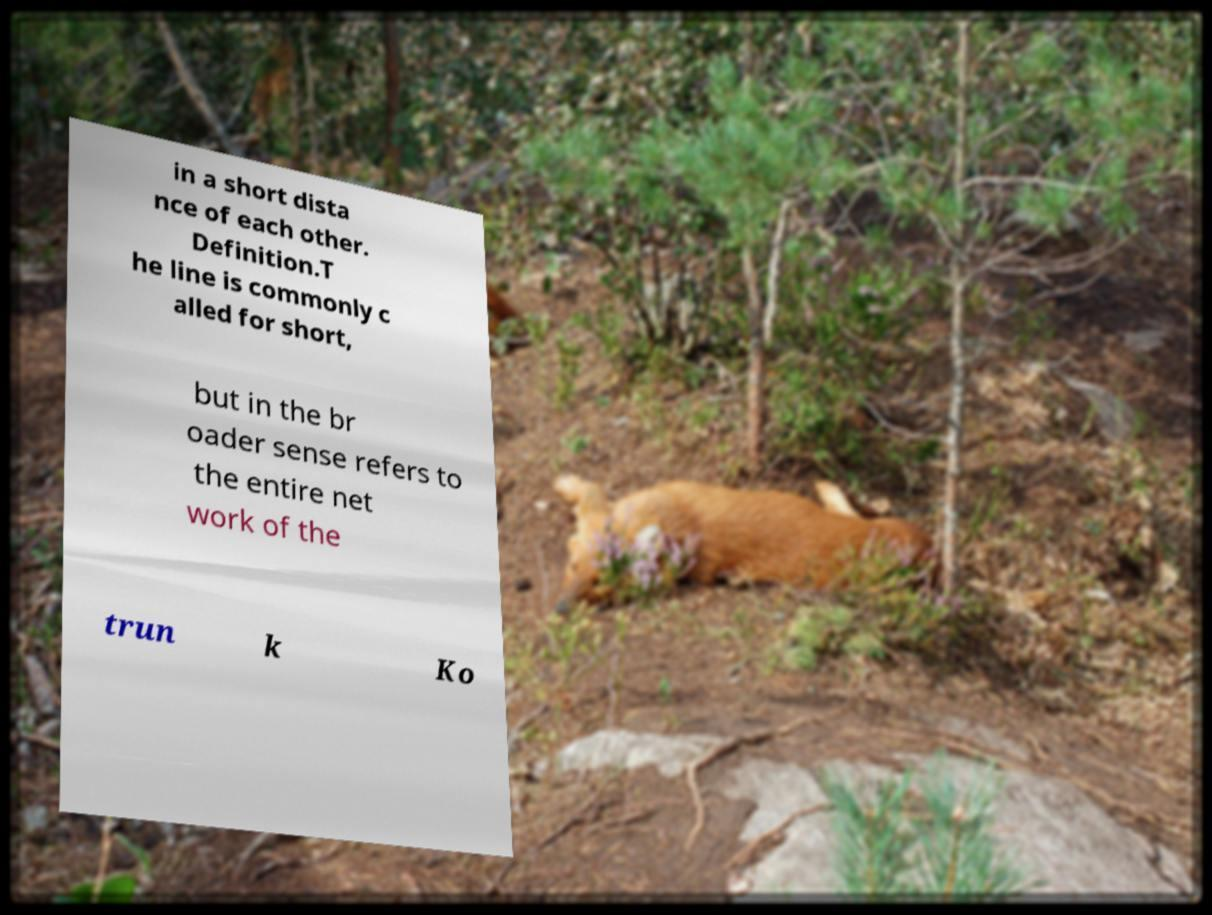Please read and relay the text visible in this image. What does it say? in a short dista nce of each other. Definition.T he line is commonly c alled for short, but in the br oader sense refers to the entire net work of the trun k Ko 